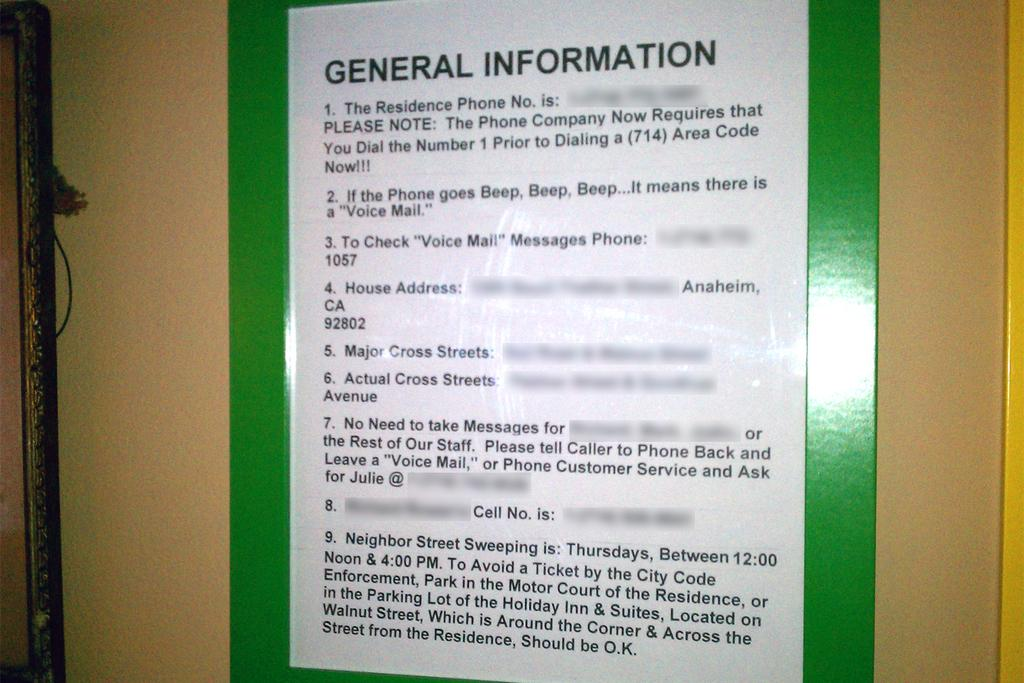Provide a one-sentence caption for the provided image. A written notice notes general information on a board. 